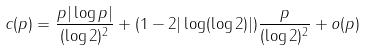Convert formula to latex. <formula><loc_0><loc_0><loc_500><loc_500>c ( p ) = \frac { p | \log p | } { ( \log 2 ) ^ { 2 } } + ( 1 - 2 | \log ( \log 2 ) | ) \frac { p } { ( \log 2 ) ^ { 2 } } + o ( p )</formula> 